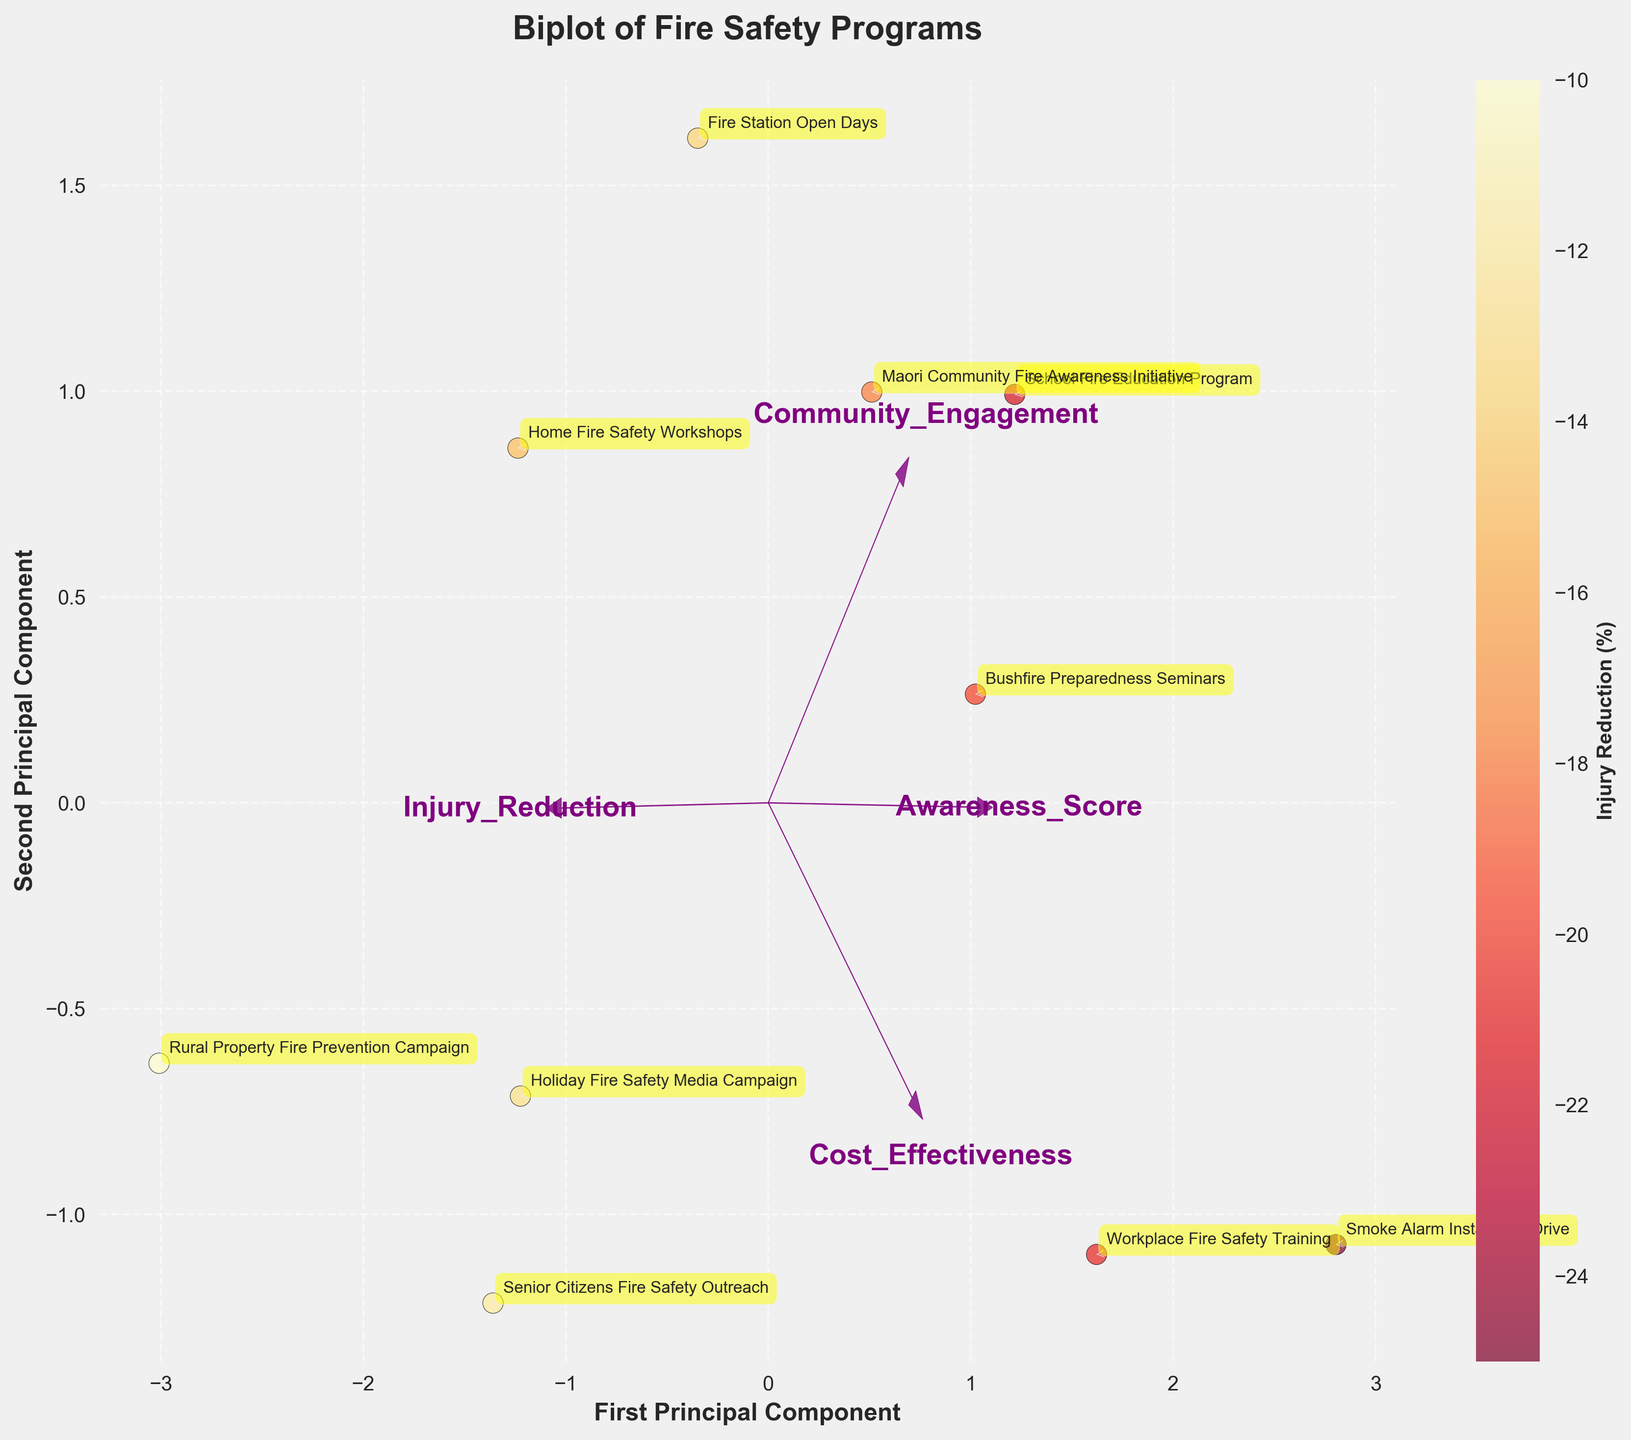what is the title of the figure? The title is typically the largest text at the top of the plot. In this case, it says "Biplot of Fire Safety Programs".
Answer: Biplot of Fire Safety Programs How many fire safety programs are presented in the plot? Each data point in the scatter plot represents a fire safety program, and there are labels next to them. Counting these labels gives the total number of programs.
Answer: 10 Which fire safety program exhibits the highest reduction in fire injuries? The color bar indicates that darker shades represent higher reductions in fire injuries. Observing the scatter points, the "Smoke Alarm Installation Drive" is the darkest point indicating a -25% reduction.
Answer: Smoke Alarm Installation Drive Which axis corresponds to the “First Principal Component”? Axes labels are typically placed along the x and y axes. In this plot, the x-axis is labeled "First Principal Component".
Answer: x-axis What are the two factors that have the largest loadings on the first principal component? These factors can be identified by examining which arrows are longest in the direction of the first principal component. In this plot, "Awareness_Score" and "Cost_Effectiveness" have the largest loadings in this direction.
Answer: Awareness_Score and Cost_Effectiveness Does the "School Fire Education Program" show a positive or negative score on the second principal component? The position of this program relative to the y-axis (Second Principal Component) is above or below zero. The "School Fire Education Program" is positioned above the zero line on the y-axis.
Answer: Positive How are "Community_Engagement" and "Cost_Effectiveness" related in this biplot? By observing the arrows representing these variables, their directions indicate if there's a positive or negative relationship. Here, the arrows for "Community_Engagement" and "Cost_Effectiveness" point in similar directions, indicating a positive relationship.
Answer: Positive relationship Which fire safety program is most closely associated with high community engagement but the least cost-effective? By looking at the program closest to the arrow signifying "Community_Engagement" and farthest from "Cost_Effectiveness", the "Maori Community Fire Awareness Initiative" fits this description.
Answer: Maori Community Fire Awareness Initiative What can be inferred if a program is located close to the origin of the biplot? Programs located near the origin of the biplot likely have average values for both principal components. This means they are not particularly high or low in any of the measured variables.
Answer: Average in all measured variables 